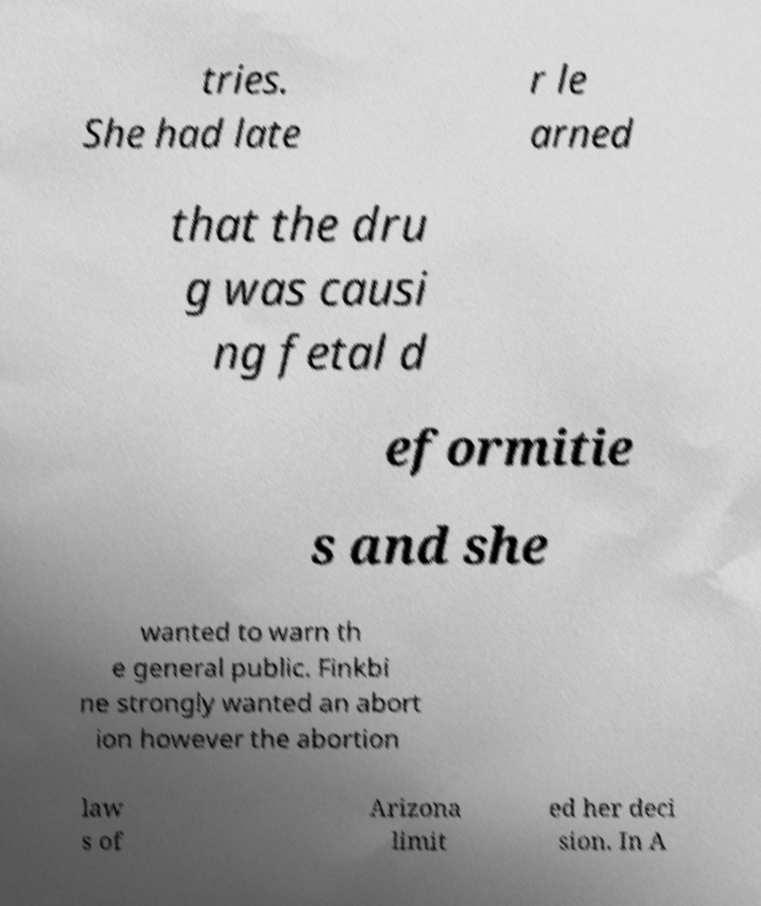Can you accurately transcribe the text from the provided image for me? tries. She had late r le arned that the dru g was causi ng fetal d eformitie s and she wanted to warn th e general public. Finkbi ne strongly wanted an abort ion however the abortion law s of Arizona limit ed her deci sion. In A 